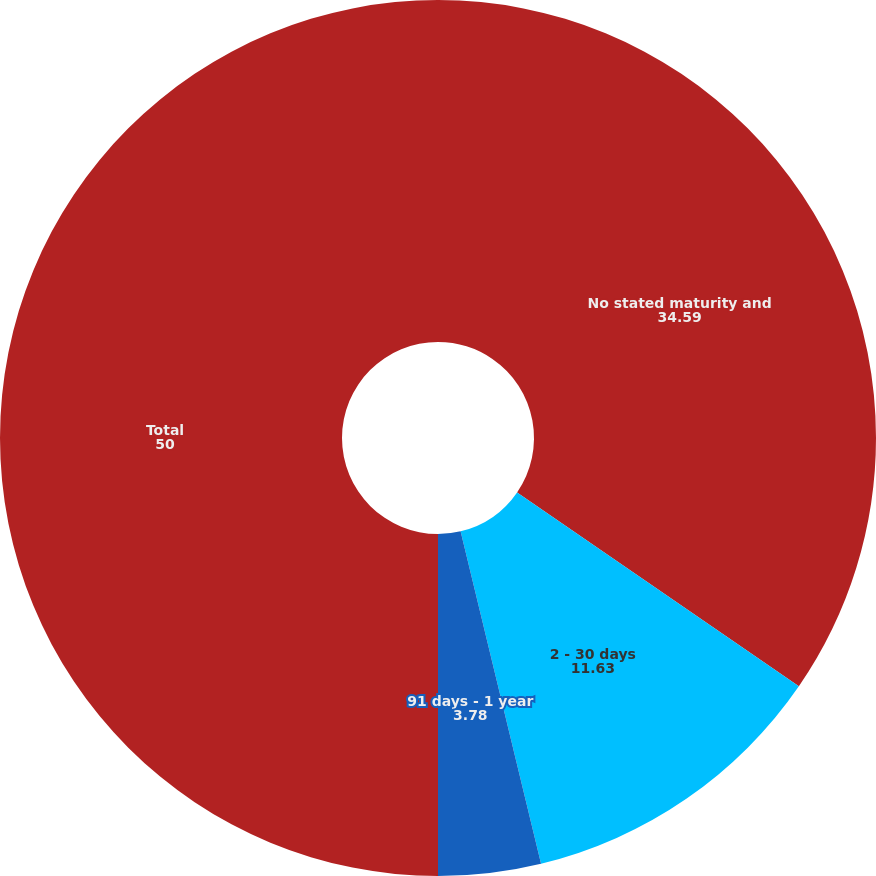<chart> <loc_0><loc_0><loc_500><loc_500><pie_chart><fcel>No stated maturity and<fcel>2 - 30 days<fcel>91 days - 1 year<fcel>Total<nl><fcel>34.59%<fcel>11.63%<fcel>3.78%<fcel>50.0%<nl></chart> 